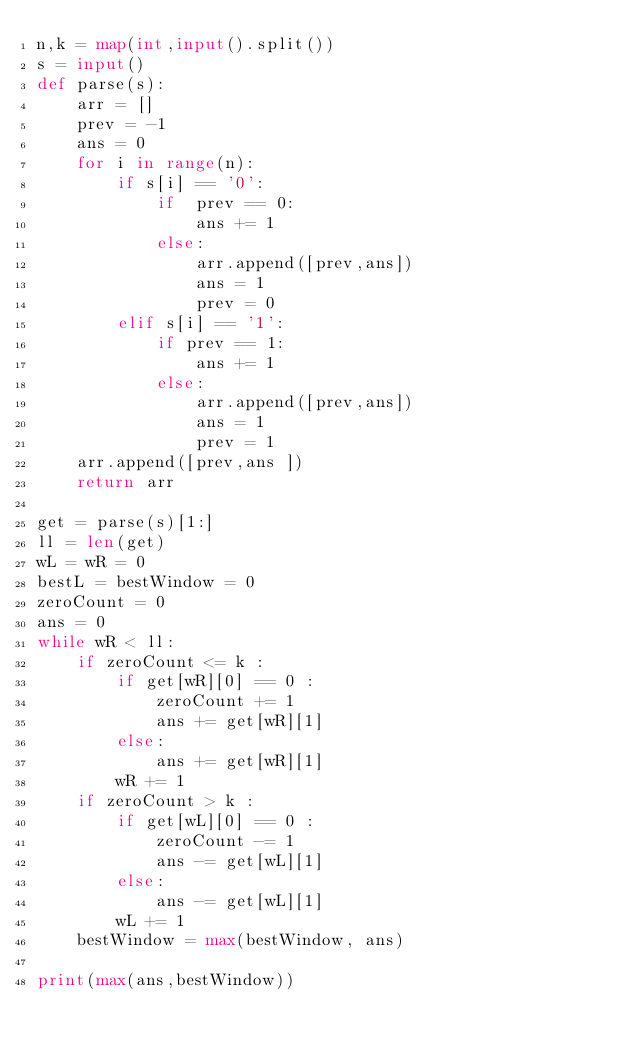<code> <loc_0><loc_0><loc_500><loc_500><_Python_>n,k = map(int,input().split())
s = input()
def parse(s):
    arr = []
    prev = -1
    ans = 0
    for i in range(n):
        if s[i] == '0':
            if  prev == 0:
                ans += 1
            else:
                arr.append([prev,ans])
                ans = 1
                prev = 0
        elif s[i] == '1':
            if prev == 1:
                ans += 1
            else:
                arr.append([prev,ans])
                ans = 1
                prev = 1
    arr.append([prev,ans ])
    return arr

get = parse(s)[1:]
ll = len(get)
wL = wR = 0
bestL = bestWindow = 0
zeroCount = 0
ans = 0
while wR < ll:
    if zeroCount <= k :
        if get[wR][0] == 0 :
            zeroCount += 1
            ans += get[wR][1]
        else:
            ans += get[wR][1]
        wR += 1
    if zeroCount > k :
        if get[wL][0] == 0 :
            zeroCount -= 1
            ans -= get[wL][1]
        else:
            ans -= get[wL][1]
        wL += 1
    bestWindow = max(bestWindow, ans)

print(max(ans,bestWindow))
</code> 